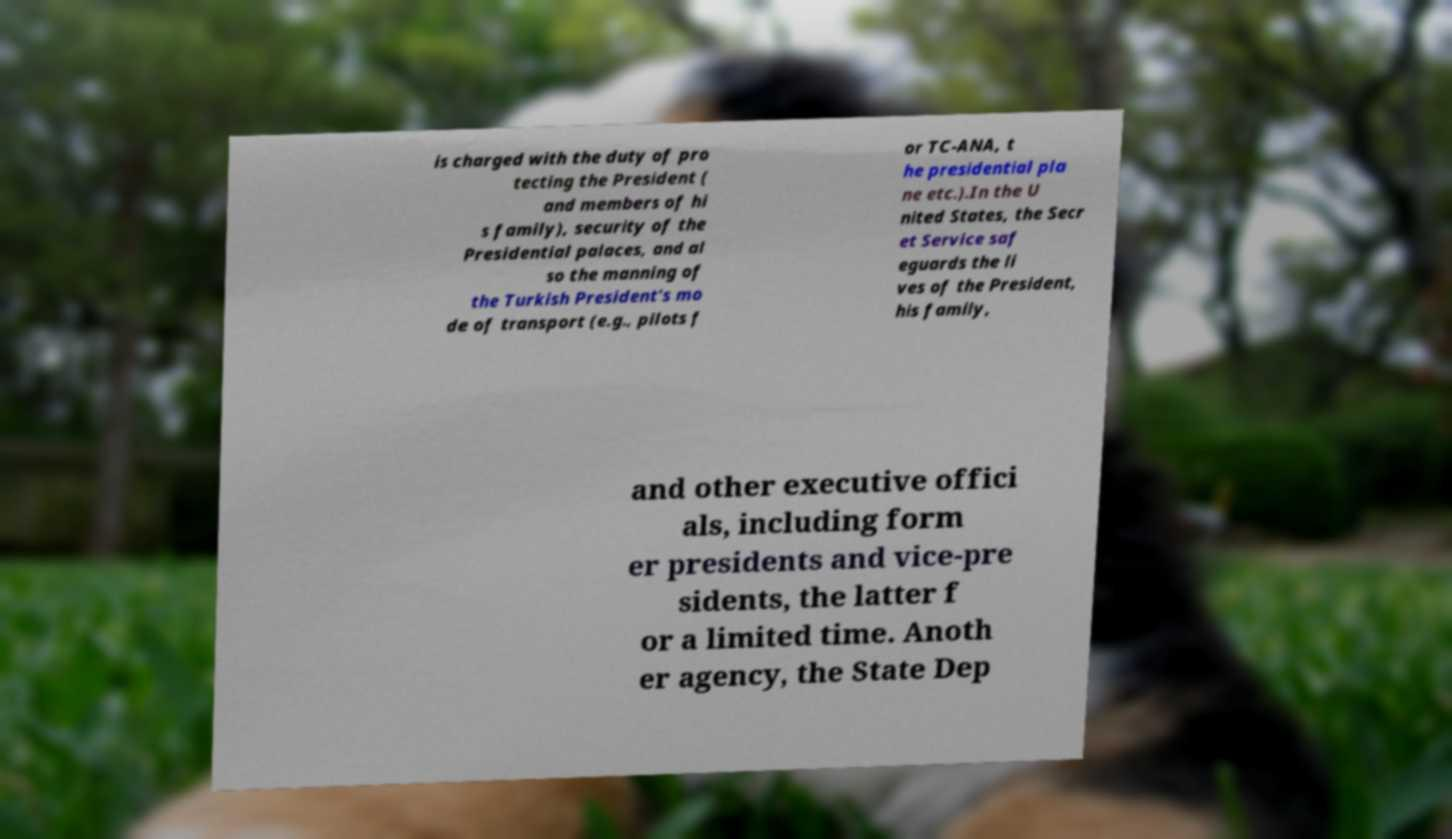What messages or text are displayed in this image? I need them in a readable, typed format. is charged with the duty of pro tecting the President ( and members of hi s family), security of the Presidential palaces, and al so the manning of the Turkish President's mo de of transport (e.g., pilots f or TC-ANA, t he presidential pla ne etc.).In the U nited States, the Secr et Service saf eguards the li ves of the President, his family, and other executive offici als, including form er presidents and vice-pre sidents, the latter f or a limited time. Anoth er agency, the State Dep 